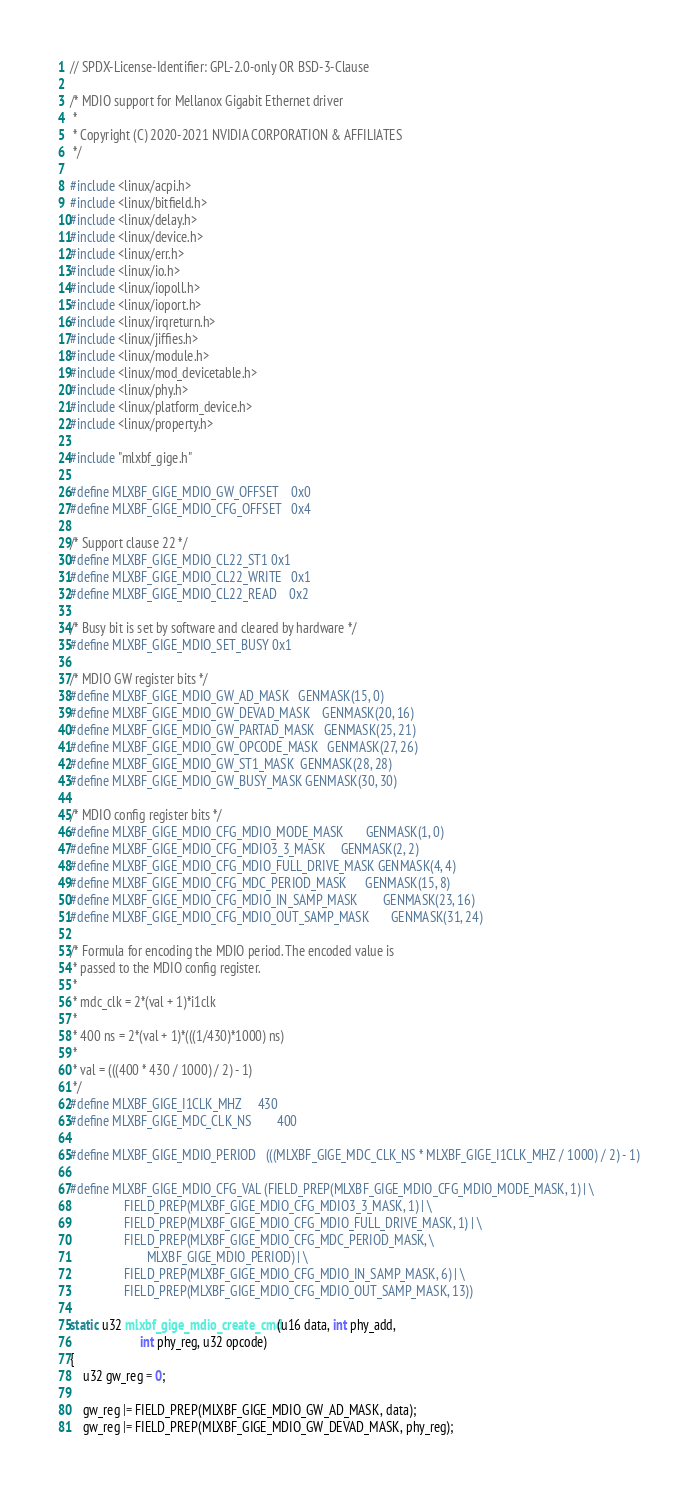<code> <loc_0><loc_0><loc_500><loc_500><_C_>// SPDX-License-Identifier: GPL-2.0-only OR BSD-3-Clause

/* MDIO support for Mellanox Gigabit Ethernet driver
 *
 * Copyright (C) 2020-2021 NVIDIA CORPORATION & AFFILIATES
 */

#include <linux/acpi.h>
#include <linux/bitfield.h>
#include <linux/delay.h>
#include <linux/device.h>
#include <linux/err.h>
#include <linux/io.h>
#include <linux/iopoll.h>
#include <linux/ioport.h>
#include <linux/irqreturn.h>
#include <linux/jiffies.h>
#include <linux/module.h>
#include <linux/mod_devicetable.h>
#include <linux/phy.h>
#include <linux/platform_device.h>
#include <linux/property.h>

#include "mlxbf_gige.h"

#define MLXBF_GIGE_MDIO_GW_OFFSET	0x0
#define MLXBF_GIGE_MDIO_CFG_OFFSET	0x4

/* Support clause 22 */
#define MLXBF_GIGE_MDIO_CL22_ST1	0x1
#define MLXBF_GIGE_MDIO_CL22_WRITE	0x1
#define MLXBF_GIGE_MDIO_CL22_READ	0x2

/* Busy bit is set by software and cleared by hardware */
#define MLXBF_GIGE_MDIO_SET_BUSY	0x1

/* MDIO GW register bits */
#define MLXBF_GIGE_MDIO_GW_AD_MASK	GENMASK(15, 0)
#define MLXBF_GIGE_MDIO_GW_DEVAD_MASK	GENMASK(20, 16)
#define MLXBF_GIGE_MDIO_GW_PARTAD_MASK	GENMASK(25, 21)
#define MLXBF_GIGE_MDIO_GW_OPCODE_MASK	GENMASK(27, 26)
#define MLXBF_GIGE_MDIO_GW_ST1_MASK	GENMASK(28, 28)
#define MLXBF_GIGE_MDIO_GW_BUSY_MASK	GENMASK(30, 30)

/* MDIO config register bits */
#define MLXBF_GIGE_MDIO_CFG_MDIO_MODE_MASK		GENMASK(1, 0)
#define MLXBF_GIGE_MDIO_CFG_MDIO3_3_MASK		GENMASK(2, 2)
#define MLXBF_GIGE_MDIO_CFG_MDIO_FULL_DRIVE_MASK	GENMASK(4, 4)
#define MLXBF_GIGE_MDIO_CFG_MDC_PERIOD_MASK		GENMASK(15, 8)
#define MLXBF_GIGE_MDIO_CFG_MDIO_IN_SAMP_MASK		GENMASK(23, 16)
#define MLXBF_GIGE_MDIO_CFG_MDIO_OUT_SAMP_MASK		GENMASK(31, 24)

/* Formula for encoding the MDIO period. The encoded value is
 * passed to the MDIO config register.
 *
 * mdc_clk = 2*(val + 1)*i1clk
 *
 * 400 ns = 2*(val + 1)*(((1/430)*1000) ns)
 *
 * val = (((400 * 430 / 1000) / 2) - 1)
 */
#define MLXBF_GIGE_I1CLK_MHZ		430
#define MLXBF_GIGE_MDC_CLK_NS		400

#define MLXBF_GIGE_MDIO_PERIOD	(((MLXBF_GIGE_MDC_CLK_NS * MLXBF_GIGE_I1CLK_MHZ / 1000) / 2) - 1)

#define MLXBF_GIGE_MDIO_CFG_VAL (FIELD_PREP(MLXBF_GIGE_MDIO_CFG_MDIO_MODE_MASK, 1) | \
				 FIELD_PREP(MLXBF_GIGE_MDIO_CFG_MDIO3_3_MASK, 1) | \
				 FIELD_PREP(MLXBF_GIGE_MDIO_CFG_MDIO_FULL_DRIVE_MASK, 1) | \
				 FIELD_PREP(MLXBF_GIGE_MDIO_CFG_MDC_PERIOD_MASK, \
					    MLXBF_GIGE_MDIO_PERIOD) | \
				 FIELD_PREP(MLXBF_GIGE_MDIO_CFG_MDIO_IN_SAMP_MASK, 6) | \
				 FIELD_PREP(MLXBF_GIGE_MDIO_CFG_MDIO_OUT_SAMP_MASK, 13))

static u32 mlxbf_gige_mdio_create_cmd(u16 data, int phy_add,
				      int phy_reg, u32 opcode)
{
	u32 gw_reg = 0;

	gw_reg |= FIELD_PREP(MLXBF_GIGE_MDIO_GW_AD_MASK, data);
	gw_reg |= FIELD_PREP(MLXBF_GIGE_MDIO_GW_DEVAD_MASK, phy_reg);</code> 